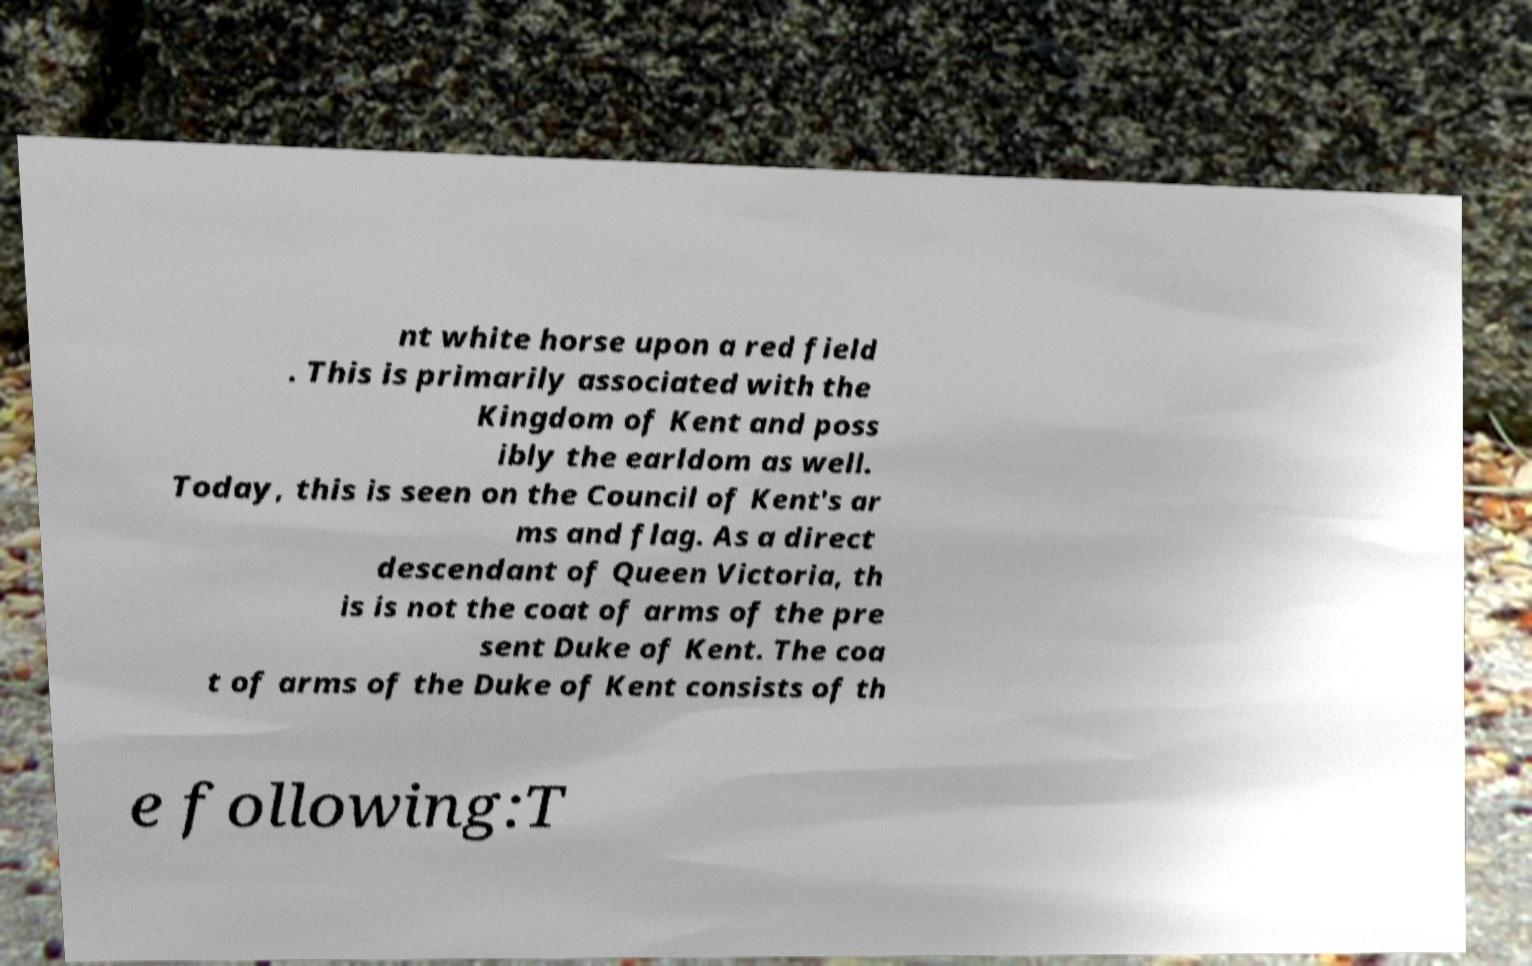Can you read and provide the text displayed in the image?This photo seems to have some interesting text. Can you extract and type it out for me? nt white horse upon a red field . This is primarily associated with the Kingdom of Kent and poss ibly the earldom as well. Today, this is seen on the Council of Kent's ar ms and flag. As a direct descendant of Queen Victoria, th is is not the coat of arms of the pre sent Duke of Kent. The coa t of arms of the Duke of Kent consists of th e following:T 